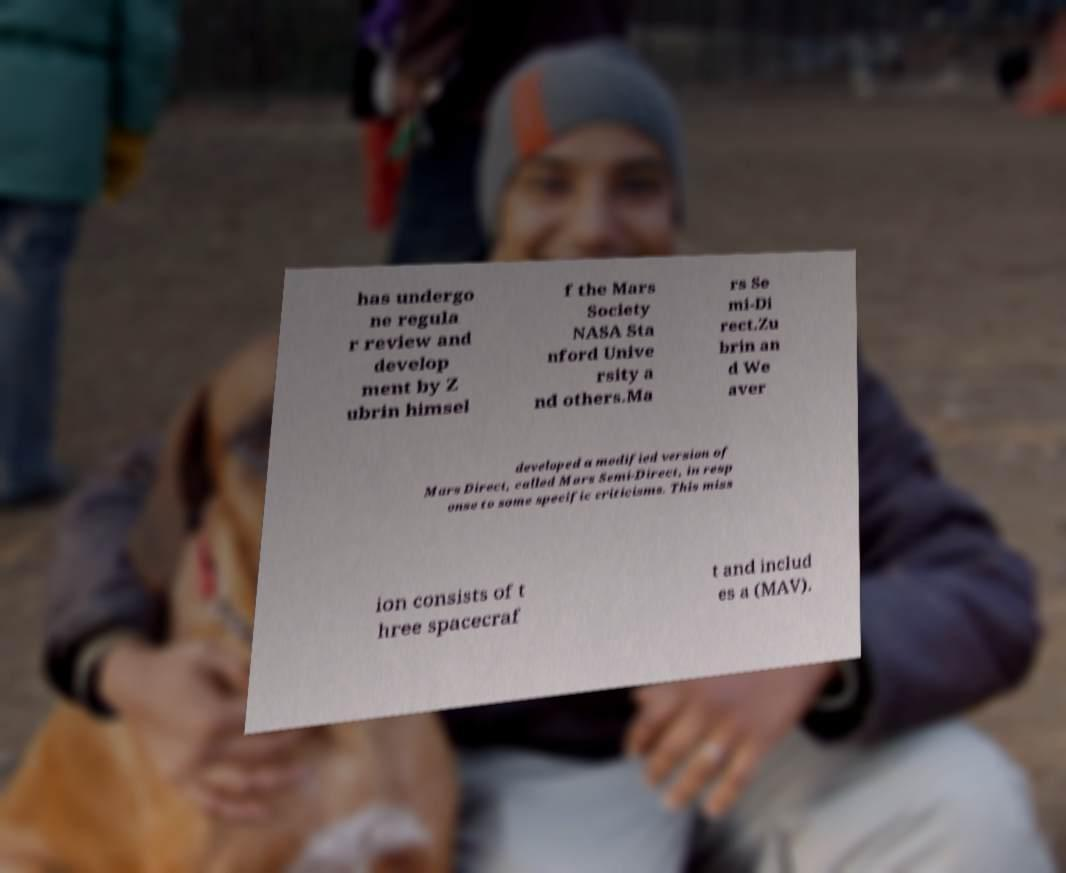There's text embedded in this image that I need extracted. Can you transcribe it verbatim? has undergo ne regula r review and develop ment by Z ubrin himsel f the Mars Society NASA Sta nford Unive rsity a nd others.Ma rs Se mi-Di rect.Zu brin an d We aver developed a modified version of Mars Direct, called Mars Semi-Direct, in resp onse to some specific criticisms. This miss ion consists of t hree spacecraf t and includ es a (MAV). 